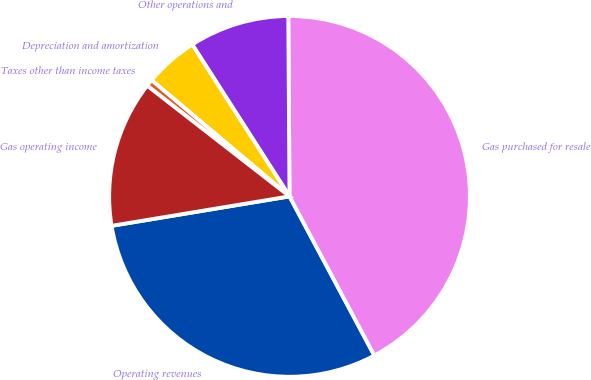Convert chart to OTSL. <chart><loc_0><loc_0><loc_500><loc_500><pie_chart><fcel>Operating revenues<fcel>Gas purchased for resale<fcel>Other operations and<fcel>Depreciation and amortization<fcel>Taxes other than income taxes<fcel>Gas operating income<nl><fcel>30.18%<fcel>42.31%<fcel>8.96%<fcel>4.79%<fcel>0.62%<fcel>13.13%<nl></chart> 